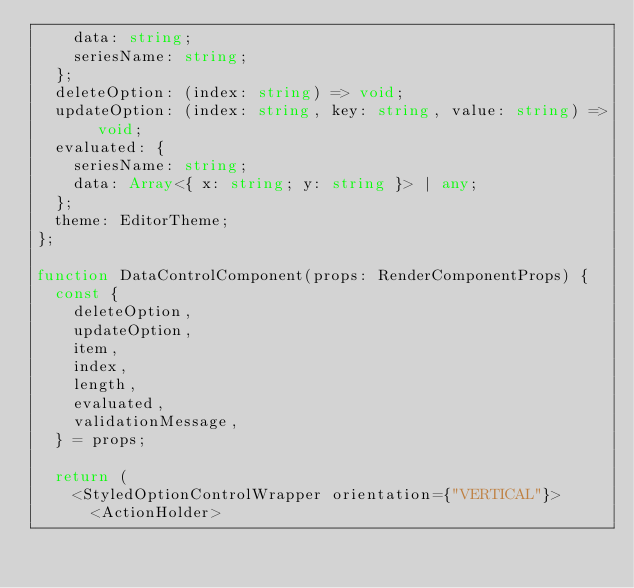<code> <loc_0><loc_0><loc_500><loc_500><_TypeScript_>    data: string;
    seriesName: string;
  };
  deleteOption: (index: string) => void;
  updateOption: (index: string, key: string, value: string) => void;
  evaluated: {
    seriesName: string;
    data: Array<{ x: string; y: string }> | any;
  };
  theme: EditorTheme;
};

function DataControlComponent(props: RenderComponentProps) {
  const {
    deleteOption,
    updateOption,
    item,
    index,
    length,
    evaluated,
    validationMessage,
  } = props;

  return (
    <StyledOptionControlWrapper orientation={"VERTICAL"}>
      <ActionHolder></code> 